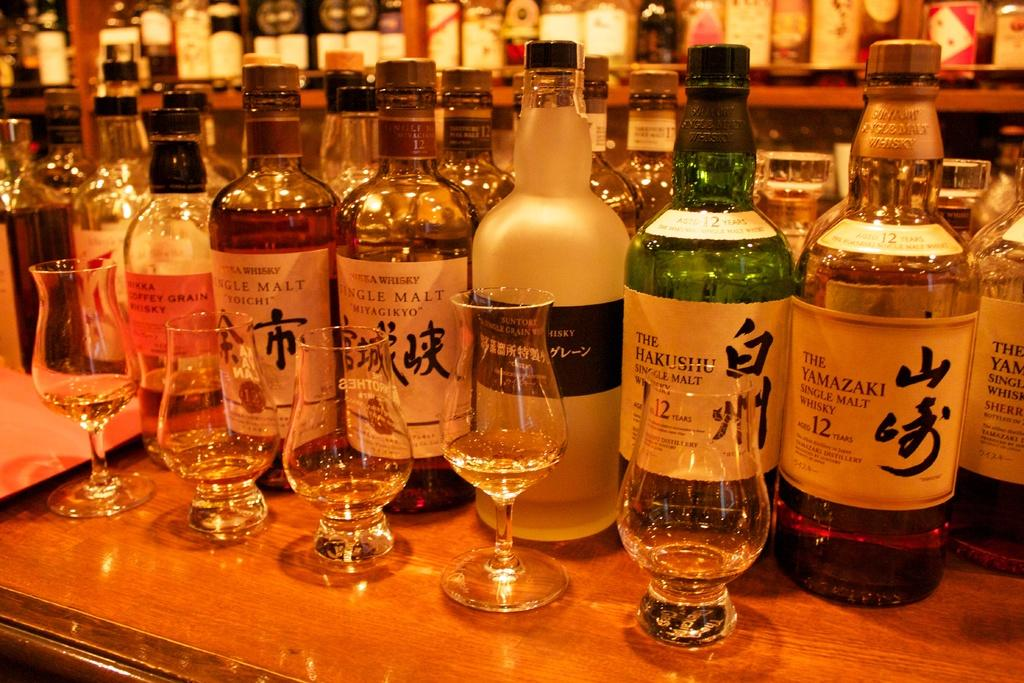<image>
Give a short and clear explanation of the subsequent image. A bottle of The Yamazaki on a bar with many other bottles of alcohol. 